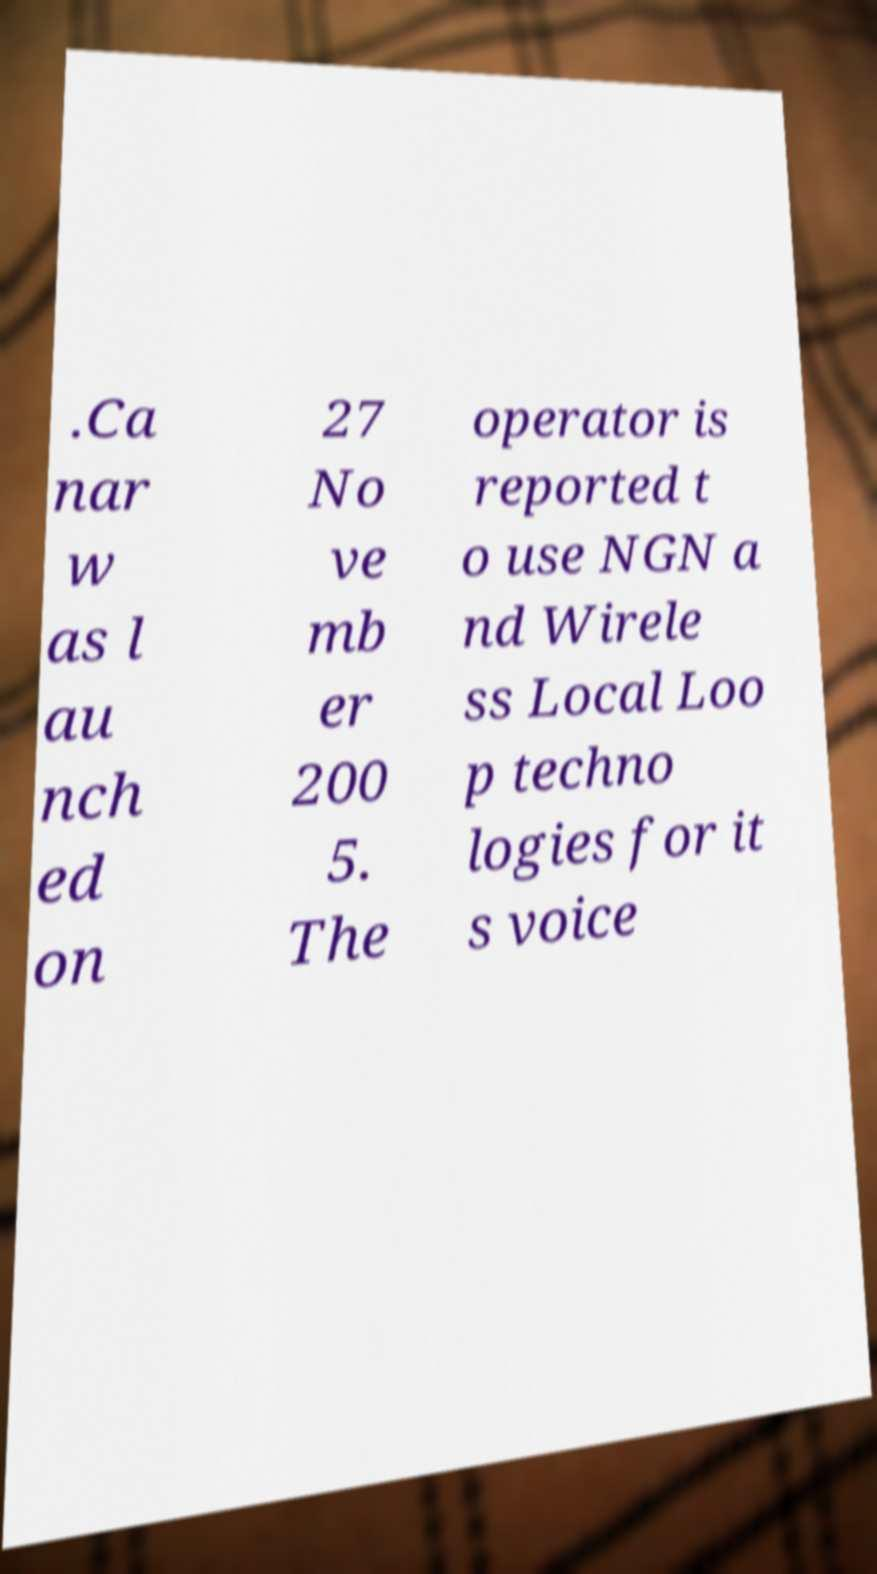For documentation purposes, I need the text within this image transcribed. Could you provide that? .Ca nar w as l au nch ed on 27 No ve mb er 200 5. The operator is reported t o use NGN a nd Wirele ss Local Loo p techno logies for it s voice 